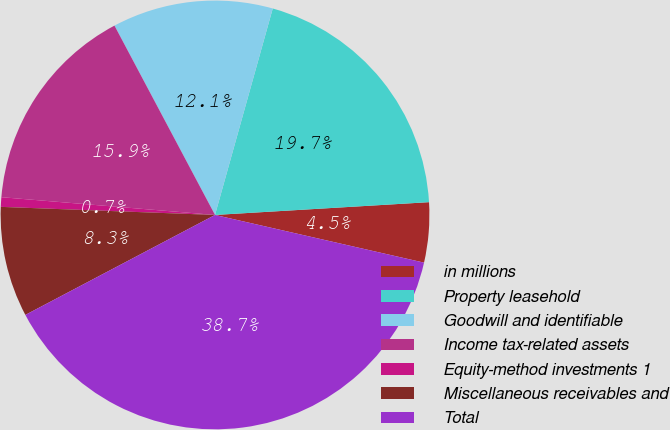Convert chart to OTSL. <chart><loc_0><loc_0><loc_500><loc_500><pie_chart><fcel>in millions<fcel>Property leasehold<fcel>Goodwill and identifiable<fcel>Income tax-related assets<fcel>Equity-method investments 1<fcel>Miscellaneous receivables and<fcel>Total<nl><fcel>4.52%<fcel>19.71%<fcel>12.11%<fcel>15.91%<fcel>0.72%<fcel>8.32%<fcel>38.71%<nl></chart> 